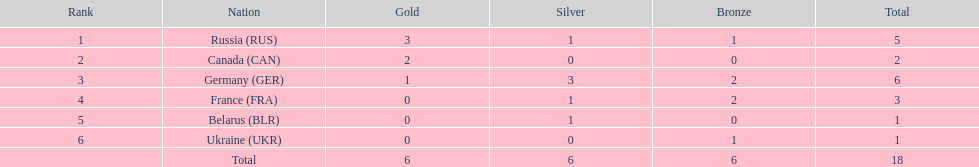Which nation secured the highest number of total medals in the biathlon event at the 1994 winter olympics? Germany (GER). 